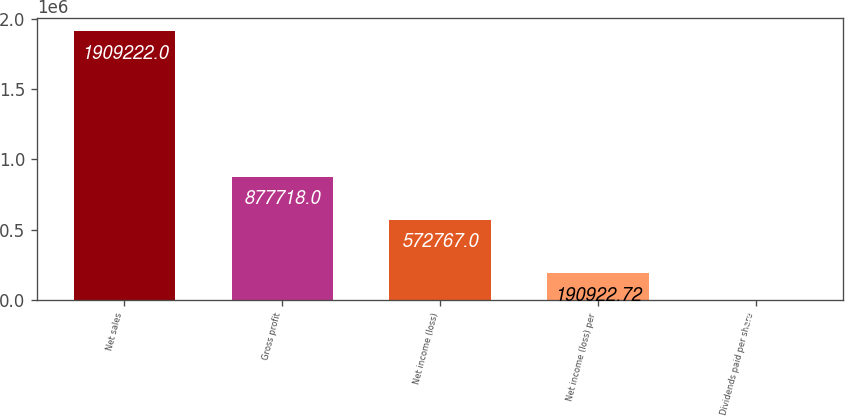Convert chart to OTSL. <chart><loc_0><loc_0><loc_500><loc_500><bar_chart><fcel>Net sales<fcel>Gross profit<fcel>Net income (loss)<fcel>Net income (loss) per<fcel>Dividends paid per share<nl><fcel>1.90922e+06<fcel>877718<fcel>572767<fcel>190923<fcel>0.58<nl></chart> 